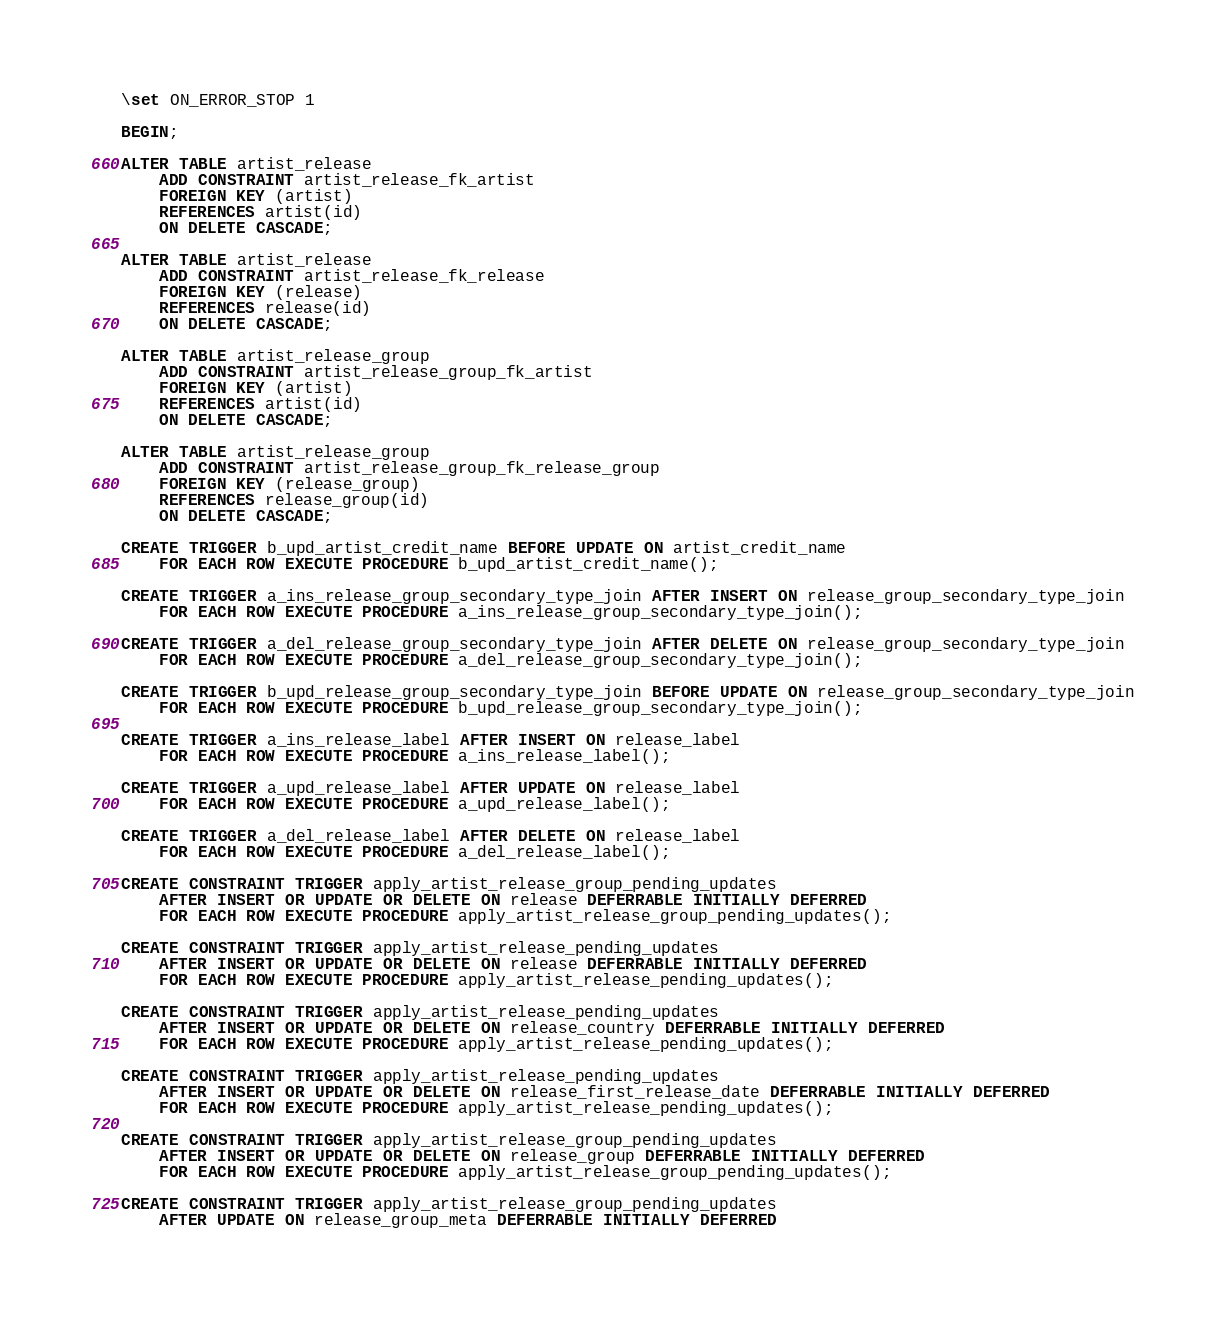Convert code to text. <code><loc_0><loc_0><loc_500><loc_500><_SQL_>\set ON_ERROR_STOP 1

BEGIN;

ALTER TABLE artist_release
    ADD CONSTRAINT artist_release_fk_artist
    FOREIGN KEY (artist)
    REFERENCES artist(id)
    ON DELETE CASCADE;

ALTER TABLE artist_release
    ADD CONSTRAINT artist_release_fk_release
    FOREIGN KEY (release)
    REFERENCES release(id)
    ON DELETE CASCADE;

ALTER TABLE artist_release_group
    ADD CONSTRAINT artist_release_group_fk_artist
    FOREIGN KEY (artist)
    REFERENCES artist(id)
    ON DELETE CASCADE;

ALTER TABLE artist_release_group
    ADD CONSTRAINT artist_release_group_fk_release_group
    FOREIGN KEY (release_group)
    REFERENCES release_group(id)
    ON DELETE CASCADE;

CREATE TRIGGER b_upd_artist_credit_name BEFORE UPDATE ON artist_credit_name
    FOR EACH ROW EXECUTE PROCEDURE b_upd_artist_credit_name();

CREATE TRIGGER a_ins_release_group_secondary_type_join AFTER INSERT ON release_group_secondary_type_join
    FOR EACH ROW EXECUTE PROCEDURE a_ins_release_group_secondary_type_join();

CREATE TRIGGER a_del_release_group_secondary_type_join AFTER DELETE ON release_group_secondary_type_join
    FOR EACH ROW EXECUTE PROCEDURE a_del_release_group_secondary_type_join();

CREATE TRIGGER b_upd_release_group_secondary_type_join BEFORE UPDATE ON release_group_secondary_type_join
    FOR EACH ROW EXECUTE PROCEDURE b_upd_release_group_secondary_type_join();

CREATE TRIGGER a_ins_release_label AFTER INSERT ON release_label
    FOR EACH ROW EXECUTE PROCEDURE a_ins_release_label();

CREATE TRIGGER a_upd_release_label AFTER UPDATE ON release_label
    FOR EACH ROW EXECUTE PROCEDURE a_upd_release_label();

CREATE TRIGGER a_del_release_label AFTER DELETE ON release_label
    FOR EACH ROW EXECUTE PROCEDURE a_del_release_label();

CREATE CONSTRAINT TRIGGER apply_artist_release_group_pending_updates
    AFTER INSERT OR UPDATE OR DELETE ON release DEFERRABLE INITIALLY DEFERRED
    FOR EACH ROW EXECUTE PROCEDURE apply_artist_release_group_pending_updates();

CREATE CONSTRAINT TRIGGER apply_artist_release_pending_updates
    AFTER INSERT OR UPDATE OR DELETE ON release DEFERRABLE INITIALLY DEFERRED
    FOR EACH ROW EXECUTE PROCEDURE apply_artist_release_pending_updates();

CREATE CONSTRAINT TRIGGER apply_artist_release_pending_updates
    AFTER INSERT OR UPDATE OR DELETE ON release_country DEFERRABLE INITIALLY DEFERRED
    FOR EACH ROW EXECUTE PROCEDURE apply_artist_release_pending_updates();

CREATE CONSTRAINT TRIGGER apply_artist_release_pending_updates
    AFTER INSERT OR UPDATE OR DELETE ON release_first_release_date DEFERRABLE INITIALLY DEFERRED
    FOR EACH ROW EXECUTE PROCEDURE apply_artist_release_pending_updates();

CREATE CONSTRAINT TRIGGER apply_artist_release_group_pending_updates
    AFTER INSERT OR UPDATE OR DELETE ON release_group DEFERRABLE INITIALLY DEFERRED
    FOR EACH ROW EXECUTE PROCEDURE apply_artist_release_group_pending_updates();

CREATE CONSTRAINT TRIGGER apply_artist_release_group_pending_updates
    AFTER UPDATE ON release_group_meta DEFERRABLE INITIALLY DEFERRED</code> 